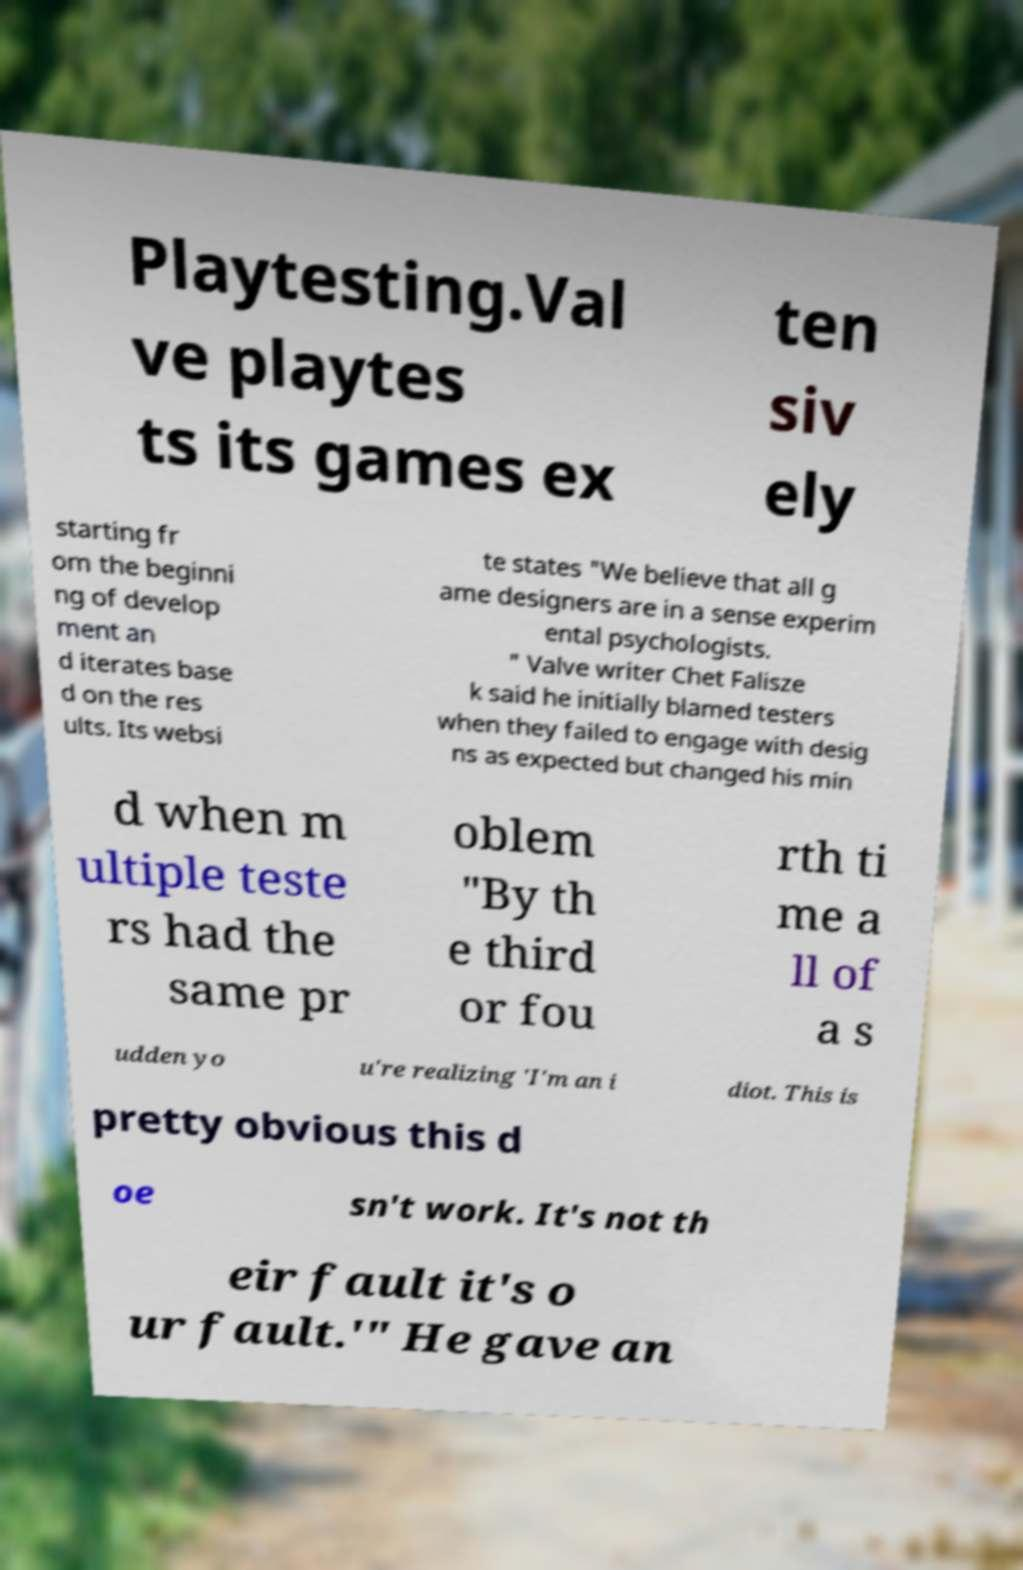Please identify and transcribe the text found in this image. Playtesting.Val ve playtes ts its games ex ten siv ely starting fr om the beginni ng of develop ment an d iterates base d on the res ults. Its websi te states "We believe that all g ame designers are in a sense experim ental psychologists. " Valve writer Chet Falisze k said he initially blamed testers when they failed to engage with desig ns as expected but changed his min d when m ultiple teste rs had the same pr oblem "By th e third or fou rth ti me a ll of a s udden yo u're realizing 'I'm an i diot. This is pretty obvious this d oe sn't work. It's not th eir fault it's o ur fault.'" He gave an 